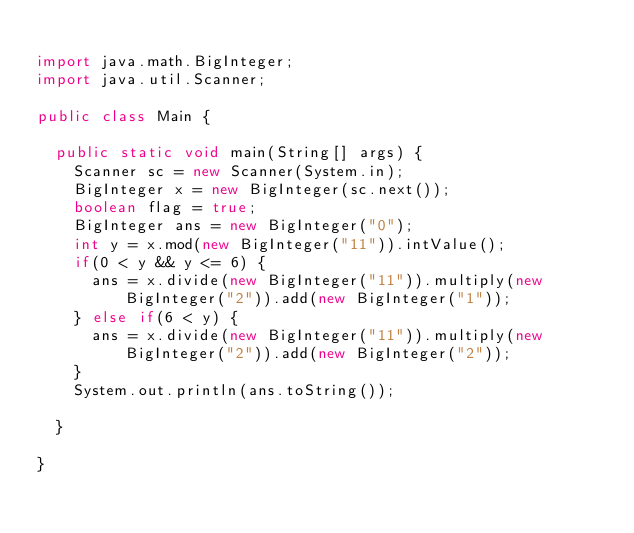<code> <loc_0><loc_0><loc_500><loc_500><_Java_>
import java.math.BigInteger;
import java.util.Scanner;

public class Main {

	public static void main(String[] args) {
		Scanner sc = new Scanner(System.in);
		BigInteger x = new BigInteger(sc.next());
		boolean flag = true;
		BigInteger ans = new BigInteger("0");
		int y = x.mod(new BigInteger("11")).intValue();
		if(0 < y && y <= 6) {
			ans = x.divide(new BigInteger("11")).multiply(new BigInteger("2")).add(new BigInteger("1"));
		} else if(6 < y) {
			ans = x.divide(new BigInteger("11")).multiply(new BigInteger("2")).add(new BigInteger("2"));
		}
		System.out.println(ans.toString());

	}

}
</code> 